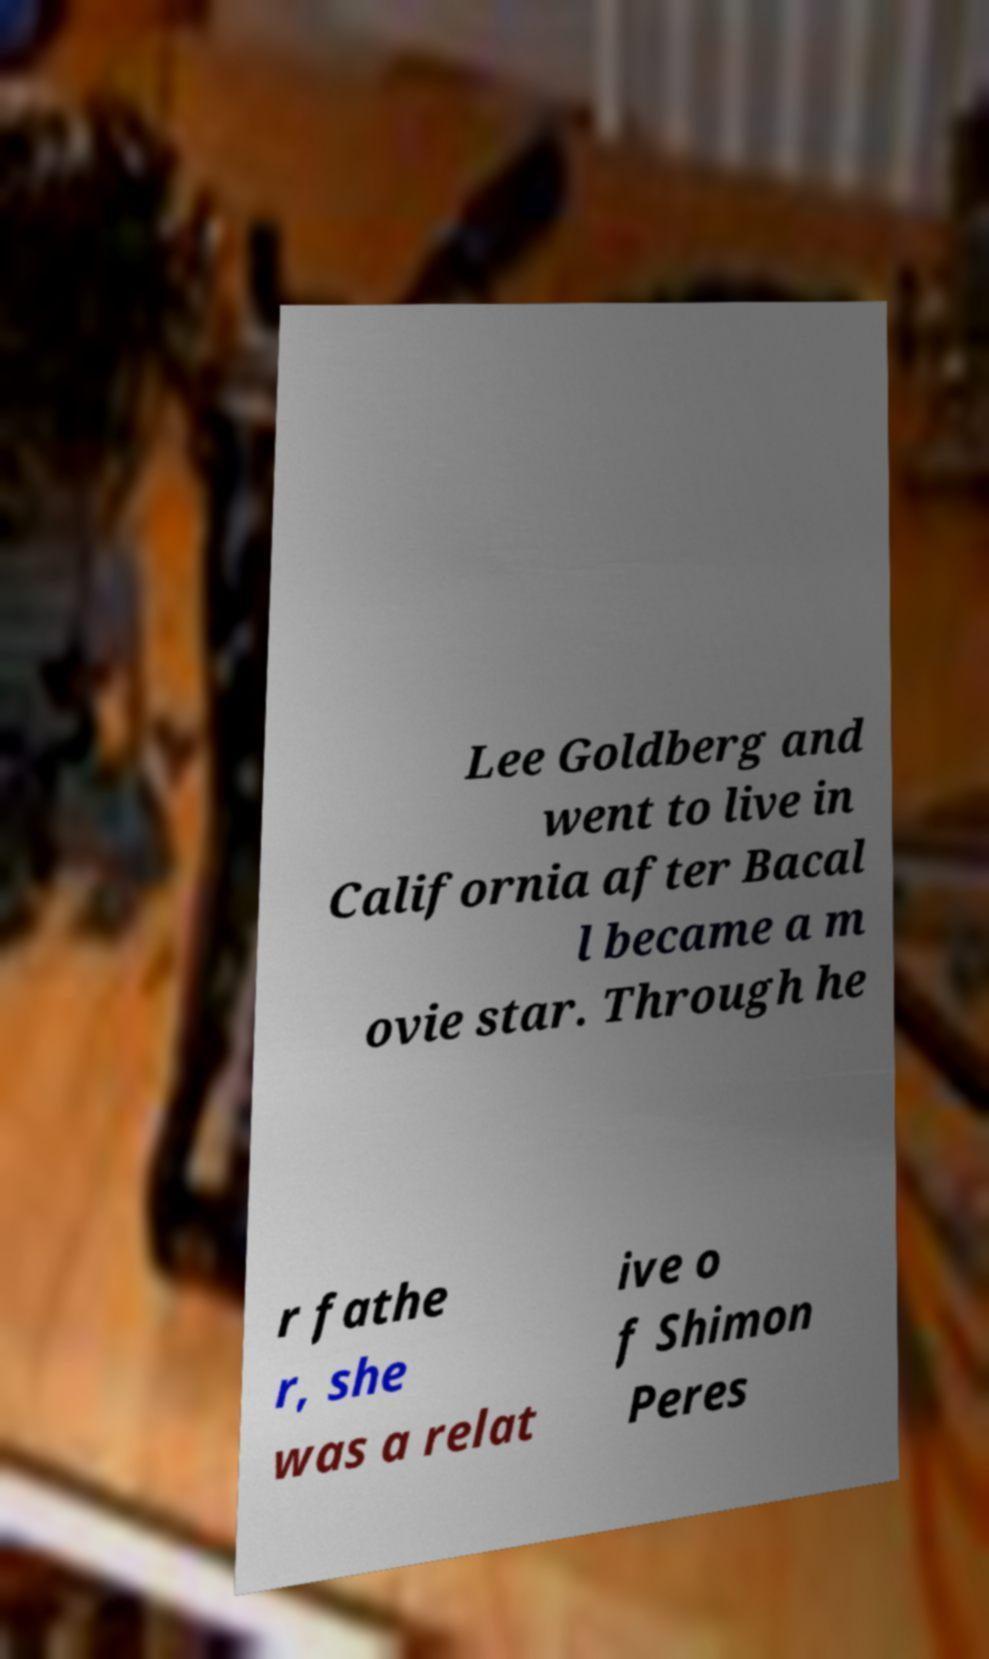Please identify and transcribe the text found in this image. Lee Goldberg and went to live in California after Bacal l became a m ovie star. Through he r fathe r, she was a relat ive o f Shimon Peres 